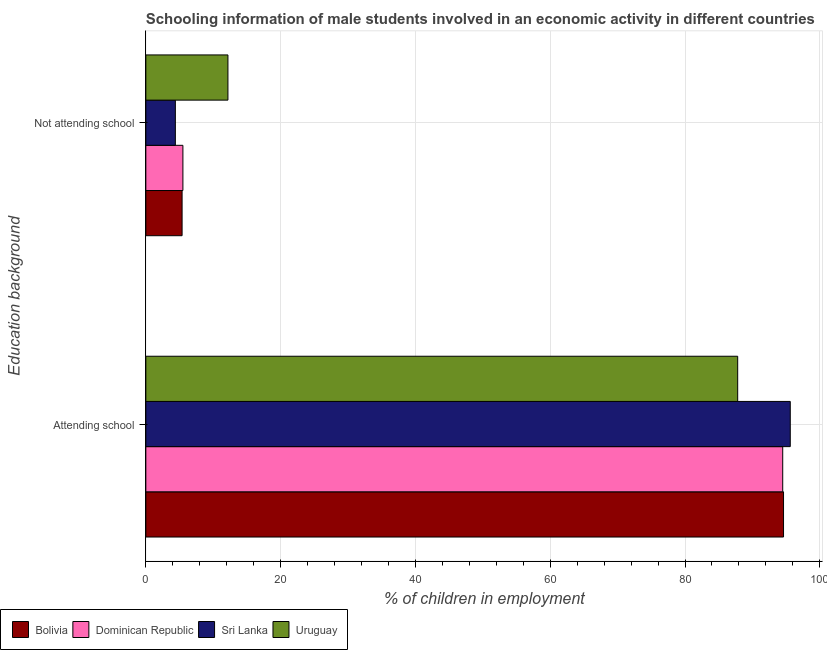How many different coloured bars are there?
Your answer should be compact. 4. Are the number of bars on each tick of the Y-axis equal?
Your answer should be very brief. Yes. How many bars are there on the 2nd tick from the bottom?
Give a very brief answer. 4. What is the label of the 1st group of bars from the top?
Give a very brief answer. Not attending school. What is the percentage of employed males who are attending school in Dominican Republic?
Ensure brevity in your answer.  94.5. Across all countries, what is the maximum percentage of employed males who are not attending school?
Your answer should be very brief. 12.18. Across all countries, what is the minimum percentage of employed males who are attending school?
Ensure brevity in your answer.  87.82. In which country was the percentage of employed males who are not attending school maximum?
Give a very brief answer. Uruguay. In which country was the percentage of employed males who are attending school minimum?
Make the answer very short. Uruguay. What is the total percentage of employed males who are attending school in the graph?
Your answer should be compact. 372.56. What is the difference between the percentage of employed males who are attending school in Sri Lanka and that in Uruguay?
Offer a terse response. 7.8. What is the difference between the percentage of employed males who are attending school in Bolivia and the percentage of employed males who are not attending school in Uruguay?
Your response must be concise. 82.44. What is the average percentage of employed males who are not attending school per country?
Provide a short and direct response. 6.86. What is the difference between the percentage of employed males who are attending school and percentage of employed males who are not attending school in Bolivia?
Ensure brevity in your answer.  89.24. What is the ratio of the percentage of employed males who are attending school in Uruguay to that in Bolivia?
Offer a very short reply. 0.93. Is the percentage of employed males who are attending school in Uruguay less than that in Sri Lanka?
Offer a very short reply. Yes. In how many countries, is the percentage of employed males who are attending school greater than the average percentage of employed males who are attending school taken over all countries?
Provide a short and direct response. 3. What does the 1st bar from the top in Attending school represents?
Ensure brevity in your answer.  Uruguay. What does the 2nd bar from the bottom in Attending school represents?
Your response must be concise. Dominican Republic. How many bars are there?
Offer a very short reply. 8. Are all the bars in the graph horizontal?
Ensure brevity in your answer.  Yes. What is the difference between two consecutive major ticks on the X-axis?
Provide a succinct answer. 20. Are the values on the major ticks of X-axis written in scientific E-notation?
Your answer should be compact. No. Does the graph contain any zero values?
Offer a terse response. No. What is the title of the graph?
Offer a terse response. Schooling information of male students involved in an economic activity in different countries. What is the label or title of the X-axis?
Your answer should be very brief. % of children in employment. What is the label or title of the Y-axis?
Give a very brief answer. Education background. What is the % of children in employment in Bolivia in Attending school?
Make the answer very short. 94.62. What is the % of children in employment of Dominican Republic in Attending school?
Keep it short and to the point. 94.5. What is the % of children in employment in Sri Lanka in Attending school?
Offer a very short reply. 95.62. What is the % of children in employment in Uruguay in Attending school?
Keep it short and to the point. 87.82. What is the % of children in employment of Bolivia in Not attending school?
Offer a very short reply. 5.38. What is the % of children in employment in Dominican Republic in Not attending school?
Your response must be concise. 5.5. What is the % of children in employment of Sri Lanka in Not attending school?
Your answer should be very brief. 4.38. What is the % of children in employment in Uruguay in Not attending school?
Offer a very short reply. 12.18. Across all Education background, what is the maximum % of children in employment of Bolivia?
Make the answer very short. 94.62. Across all Education background, what is the maximum % of children in employment of Dominican Republic?
Provide a succinct answer. 94.5. Across all Education background, what is the maximum % of children in employment of Sri Lanka?
Provide a short and direct response. 95.62. Across all Education background, what is the maximum % of children in employment of Uruguay?
Offer a terse response. 87.82. Across all Education background, what is the minimum % of children in employment of Bolivia?
Ensure brevity in your answer.  5.38. Across all Education background, what is the minimum % of children in employment of Sri Lanka?
Give a very brief answer. 4.38. Across all Education background, what is the minimum % of children in employment of Uruguay?
Keep it short and to the point. 12.18. What is the total % of children in employment of Sri Lanka in the graph?
Offer a very short reply. 100. What is the total % of children in employment in Uruguay in the graph?
Provide a short and direct response. 100. What is the difference between the % of children in employment in Bolivia in Attending school and that in Not attending school?
Your response must be concise. 89.24. What is the difference between the % of children in employment of Dominican Republic in Attending school and that in Not attending school?
Offer a very short reply. 89. What is the difference between the % of children in employment of Sri Lanka in Attending school and that in Not attending school?
Give a very brief answer. 91.24. What is the difference between the % of children in employment in Uruguay in Attending school and that in Not attending school?
Offer a terse response. 75.64. What is the difference between the % of children in employment in Bolivia in Attending school and the % of children in employment in Dominican Republic in Not attending school?
Your answer should be compact. 89.12. What is the difference between the % of children in employment of Bolivia in Attending school and the % of children in employment of Sri Lanka in Not attending school?
Provide a short and direct response. 90.24. What is the difference between the % of children in employment in Bolivia in Attending school and the % of children in employment in Uruguay in Not attending school?
Offer a very short reply. 82.44. What is the difference between the % of children in employment in Dominican Republic in Attending school and the % of children in employment in Sri Lanka in Not attending school?
Ensure brevity in your answer.  90.12. What is the difference between the % of children in employment of Dominican Republic in Attending school and the % of children in employment of Uruguay in Not attending school?
Provide a succinct answer. 82.32. What is the difference between the % of children in employment in Sri Lanka in Attending school and the % of children in employment in Uruguay in Not attending school?
Your response must be concise. 83.44. What is the difference between the % of children in employment of Bolivia and % of children in employment of Dominican Republic in Attending school?
Ensure brevity in your answer.  0.12. What is the difference between the % of children in employment in Bolivia and % of children in employment in Sri Lanka in Attending school?
Keep it short and to the point. -1. What is the difference between the % of children in employment in Bolivia and % of children in employment in Uruguay in Attending school?
Your answer should be compact. 6.8. What is the difference between the % of children in employment in Dominican Republic and % of children in employment in Sri Lanka in Attending school?
Make the answer very short. -1.12. What is the difference between the % of children in employment in Dominican Republic and % of children in employment in Uruguay in Attending school?
Make the answer very short. 6.68. What is the difference between the % of children in employment of Sri Lanka and % of children in employment of Uruguay in Attending school?
Offer a very short reply. 7.8. What is the difference between the % of children in employment in Bolivia and % of children in employment in Dominican Republic in Not attending school?
Give a very brief answer. -0.12. What is the difference between the % of children in employment in Bolivia and % of children in employment in Sri Lanka in Not attending school?
Make the answer very short. 1. What is the difference between the % of children in employment of Bolivia and % of children in employment of Uruguay in Not attending school?
Your answer should be very brief. -6.8. What is the difference between the % of children in employment in Dominican Republic and % of children in employment in Sri Lanka in Not attending school?
Provide a succinct answer. 1.12. What is the difference between the % of children in employment in Dominican Republic and % of children in employment in Uruguay in Not attending school?
Offer a very short reply. -6.68. What is the difference between the % of children in employment in Sri Lanka and % of children in employment in Uruguay in Not attending school?
Your response must be concise. -7.8. What is the ratio of the % of children in employment of Bolivia in Attending school to that in Not attending school?
Give a very brief answer. 17.59. What is the ratio of the % of children in employment of Dominican Republic in Attending school to that in Not attending school?
Offer a very short reply. 17.18. What is the ratio of the % of children in employment of Sri Lanka in Attending school to that in Not attending school?
Provide a short and direct response. 21.84. What is the ratio of the % of children in employment in Uruguay in Attending school to that in Not attending school?
Offer a terse response. 7.21. What is the difference between the highest and the second highest % of children in employment in Bolivia?
Give a very brief answer. 89.24. What is the difference between the highest and the second highest % of children in employment of Dominican Republic?
Offer a terse response. 89. What is the difference between the highest and the second highest % of children in employment of Sri Lanka?
Give a very brief answer. 91.24. What is the difference between the highest and the second highest % of children in employment in Uruguay?
Ensure brevity in your answer.  75.64. What is the difference between the highest and the lowest % of children in employment in Bolivia?
Your answer should be very brief. 89.24. What is the difference between the highest and the lowest % of children in employment of Dominican Republic?
Provide a succinct answer. 89. What is the difference between the highest and the lowest % of children in employment of Sri Lanka?
Give a very brief answer. 91.24. What is the difference between the highest and the lowest % of children in employment in Uruguay?
Your answer should be very brief. 75.64. 